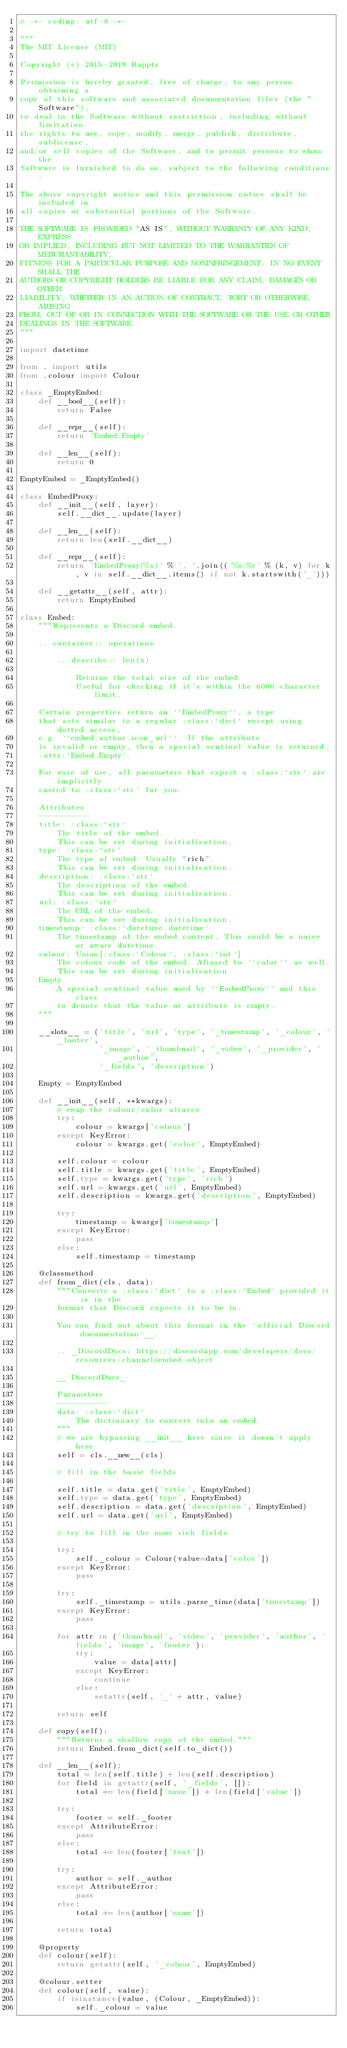Convert code to text. <code><loc_0><loc_0><loc_500><loc_500><_Python_># -*- coding: utf-8 -*-

"""
The MIT License (MIT)

Copyright (c) 2015-2019 Rapptz

Permission is hereby granted, free of charge, to any person obtaining a
copy of this software and associated documentation files (the "Software"),
to deal in the Software without restriction, including without limitation
the rights to use, copy, modify, merge, publish, distribute, sublicense,
and/or sell copies of the Software, and to permit persons to whom the
Software is furnished to do so, subject to the following conditions:

The above copyright notice and this permission notice shall be included in
all copies or substantial portions of the Software.

THE SOFTWARE IS PROVIDED "AS IS", WITHOUT WARRANTY OF ANY KIND, EXPRESS
OR IMPLIED, INCLUDING BUT NOT LIMITED TO THE WARRANTIES OF MERCHANTABILITY,
FITNESS FOR A PARTICULAR PURPOSE AND NONINFRINGEMENT. IN NO EVENT SHALL THE
AUTHORS OR COPYRIGHT HOLDERS BE LIABLE FOR ANY CLAIM, DAMAGES OR OTHER
LIABILITY, WHETHER IN AN ACTION OF CONTRACT, TORT OR OTHERWISE, ARISING
FROM, OUT OF OR IN CONNECTION WITH THE SOFTWARE OR THE USE OR OTHER
DEALINGS IN THE SOFTWARE.
"""

import datetime

from . import utils
from .colour import Colour

class _EmptyEmbed:
    def __bool__(self):
        return False

    def __repr__(self):
        return 'Embed.Empty'

    def __len__(self):
        return 0

EmptyEmbed = _EmptyEmbed()

class EmbedProxy:
    def __init__(self, layer):
        self.__dict__.update(layer)

    def __len__(self):
        return len(self.__dict__)

    def __repr__(self):
        return 'EmbedProxy(%s)' % ', '.join(('%s=%r' % (k, v) for k, v in self.__dict__.items() if not k.startswith('_')))

    def __getattr__(self, attr):
        return EmptyEmbed

class Embed:
    """Represents a Discord embed.

    .. container:: operations

        .. describe:: len(x)

            Returns the total size of the embed.
            Useful for checking if it's within the 6000 character limit.

    Certain properties return an ``EmbedProxy``, a type
    that acts similar to a regular :class:`dict` except using dotted access,
    e.g. ``embed.author.icon_url``. If the attribute
    is invalid or empty, then a special sentinel value is returned,
    :attr:`Embed.Empty`.

    For ease of use, all parameters that expect a :class:`str` are implicitly
    casted to :class:`str` for you.

    Attributes
    -----------
    title: :class:`str`
        The title of the embed.
        This can be set during initialisation.
    type: :class:`str`
        The type of embed. Usually "rich".
        This can be set during initialisation.
    description: :class:`str`
        The description of the embed.
        This can be set during initialisation.
    url: :class:`str`
        The URL of the embed.
        This can be set during initialisation.
    timestamp: :class:`datetime.datetime`
        The timestamp of the embed content. This could be a naive or aware datetime.
    colour: Union[:class:`Colour`, :class:`int`]
        The colour code of the embed. Aliased to ``color`` as well.
        This can be set during initialisation.
    Empty
        A special sentinel value used by ``EmbedProxy`` and this class
        to denote that the value or attribute is empty.
    """

    __slots__ = ('title', 'url', 'type', '_timestamp', '_colour', '_footer',
                 '_image', '_thumbnail', '_video', '_provider', '_author',
                 '_fields', 'description')

    Empty = EmptyEmbed

    def __init__(self, **kwargs):
        # swap the colour/color aliases
        try:
            colour = kwargs['colour']
        except KeyError:
            colour = kwargs.get('color', EmptyEmbed)

        self.colour = colour
        self.title = kwargs.get('title', EmptyEmbed)
        self.type = kwargs.get('type', 'rich')
        self.url = kwargs.get('url', EmptyEmbed)
        self.description = kwargs.get('description', EmptyEmbed)

        try:
            timestamp = kwargs['timestamp']
        except KeyError:
            pass
        else:
            self.timestamp = timestamp

    @classmethod
    def from_dict(cls, data):
        """Converts a :class:`dict` to a :class:`Embed` provided it is in the
        format that Discord expects it to be in.

        You can find out about this format in the `official Discord documentation`__.

        .. _DiscordDocs: https://discordapp.com/developers/docs/resources/channel#embed-object

        __ DiscordDocs_

        Parameters
        -----------
        data: :class:`dict`
            The dictionary to convert into an embed.
        """
        # we are bypassing __init__ here since it doesn't apply here
        self = cls.__new__(cls)

        # fill in the basic fields

        self.title = data.get('title', EmptyEmbed)
        self.type = data.get('type', EmptyEmbed)
        self.description = data.get('description', EmptyEmbed)
        self.url = data.get('url', EmptyEmbed)

        # try to fill in the more rich fields

        try:
            self._colour = Colour(value=data['color'])
        except KeyError:
            pass

        try:
            self._timestamp = utils.parse_time(data['timestamp'])
        except KeyError:
            pass

        for attr in ('thumbnail', 'video', 'provider', 'author', 'fields', 'image', 'footer'):
            try:
                value = data[attr]
            except KeyError:
                continue
            else:
                setattr(self, '_' + attr, value)

        return self

    def copy(self):
        """Returns a shallow copy of the embed."""
        return Embed.from_dict(self.to_dict())

    def __len__(self):
        total = len(self.title) + len(self.description)
        for field in getattr(self, '_fields', []):
            total += len(field['name']) + len(field['value'])

        try:
            footer = self._footer
        except AttributeError:
            pass
        else:
            total += len(footer['text'])

        try:
            author = self._author
        except AttributeError:
            pass
        else:
            total += len(author['name'])

        return total

    @property
    def colour(self):
        return getattr(self, '_colour', EmptyEmbed)

    @colour.setter
    def colour(self, value):
        if isinstance(value, (Colour, _EmptyEmbed)):
            self._colour = value</code> 